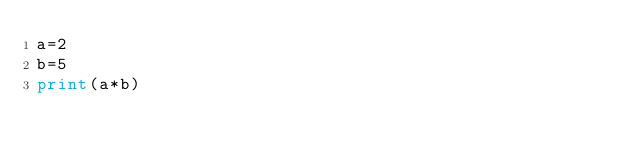Convert code to text. <code><loc_0><loc_0><loc_500><loc_500><_Python_>a=2
b=5
print(a*b)</code> 